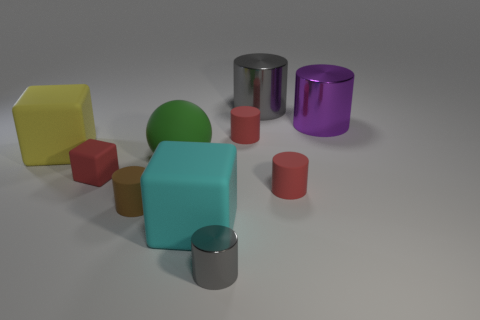Are there any red rubber blocks behind the large green ball? no 